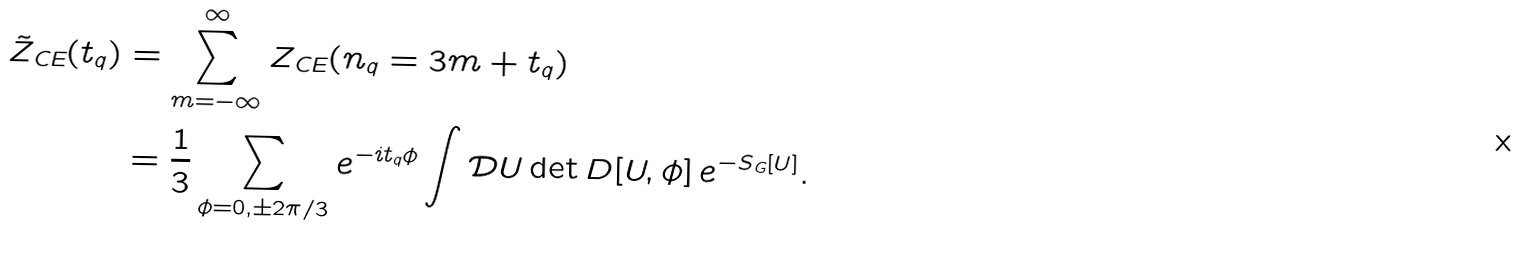Convert formula to latex. <formula><loc_0><loc_0><loc_500><loc_500>\tilde { Z } _ { \text {CE} } ( t _ { q } ) & = \sum _ { m = - \infty } ^ { \infty } Z _ { \text {CE} } ( n _ { q } = 3 m + t _ { q } ) \\ & = \frac { 1 } { 3 } \sum _ { \phi = 0 , \pm 2 \pi / 3 } e ^ { - i t _ { q } \phi } \int \mathcal { D } U \det D [ U , \phi ] \, e ^ { - S _ { \text {G} } [ U ] } .</formula> 